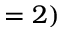Convert formula to latex. <formula><loc_0><loc_0><loc_500><loc_500>= 2 )</formula> 